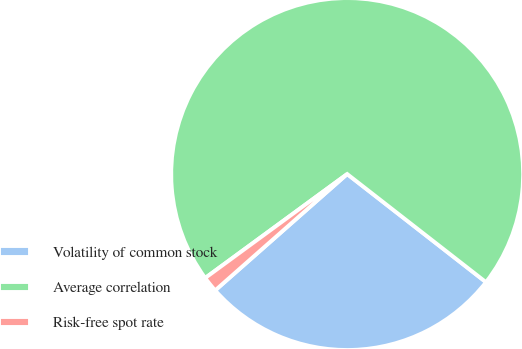Convert chart. <chart><loc_0><loc_0><loc_500><loc_500><pie_chart><fcel>Volatility of common stock<fcel>Average correlation<fcel>Risk-free spot rate<nl><fcel>27.97%<fcel>70.59%<fcel>1.44%<nl></chart> 